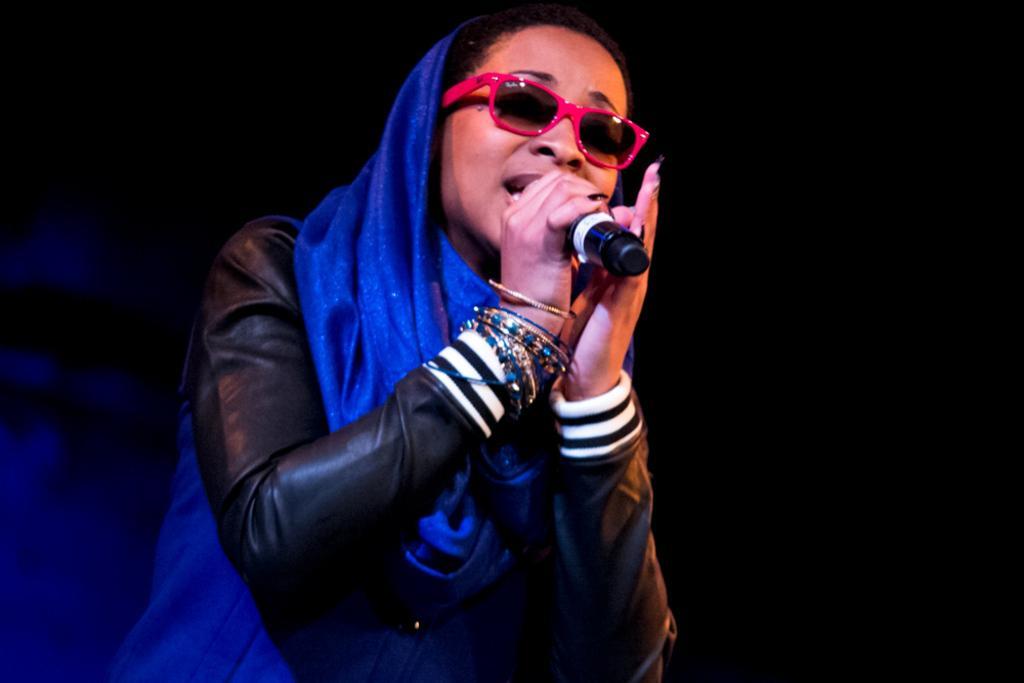Please provide a concise description of this image. As we can see in the image there is a woman wearing spectacles, blue color saree and holding a mic. 